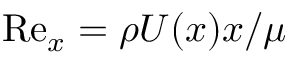Convert formula to latex. <formula><loc_0><loc_0><loc_500><loc_500>R e _ { x } = \rho U ( x ) x / \mu</formula> 